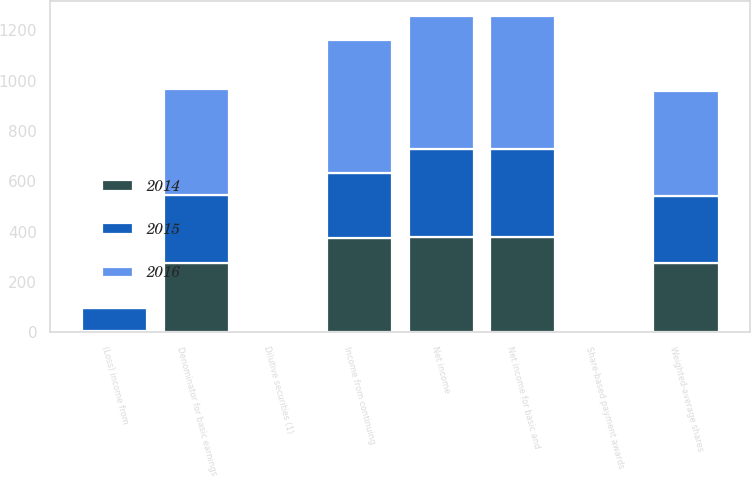Convert chart to OTSL. <chart><loc_0><loc_0><loc_500><loc_500><stacked_bar_chart><ecel><fcel>Income from continuing<fcel>(Loss) income from<fcel>Net income<fcel>Net income for basic and<fcel>Weighted-average shares<fcel>Share-based payment awards<fcel>Denominator for basic earnings<fcel>Dilutive securities (1)<nl><fcel>2016<fcel>528.5<fcel>0.7<fcel>527.8<fcel>527.8<fcel>418.3<fcel>1.5<fcel>421.3<fcel>1.8<nl><fcel>2015<fcel>259.3<fcel>90.7<fcel>350<fcel>350.1<fcel>267.9<fcel>1.4<fcel>269.3<fcel>2.2<nl><fcel>2014<fcel>373<fcel>4.8<fcel>377.8<fcel>377.9<fcel>274.2<fcel>1.9<fcel>276.1<fcel>2.8<nl></chart> 